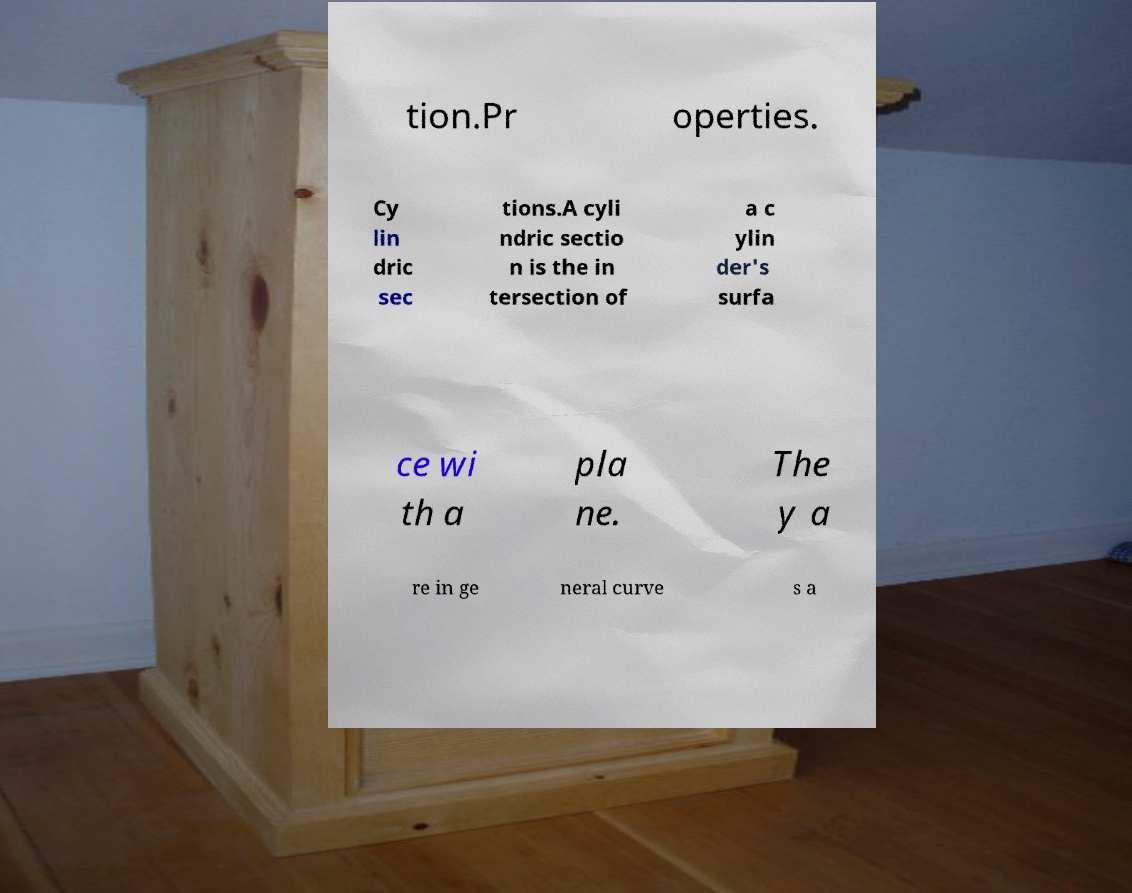I need the written content from this picture converted into text. Can you do that? tion.Pr operties. Cy lin dric sec tions.A cyli ndric sectio n is the in tersection of a c ylin der's surfa ce wi th a pla ne. The y a re in ge neral curve s a 